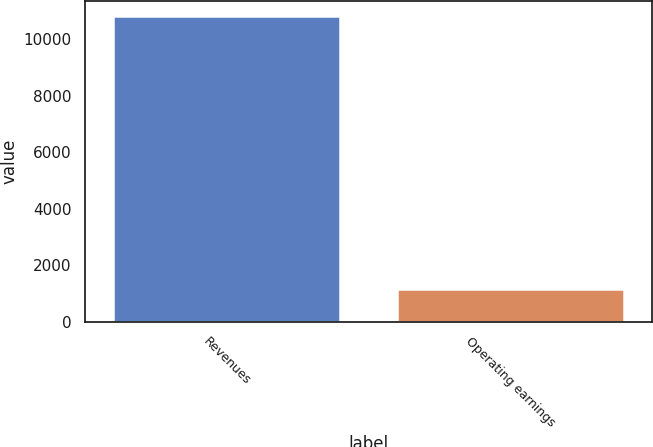Convert chart to OTSL. <chart><loc_0><loc_0><loc_500><loc_500><bar_chart><fcel>Revenues<fcel>Operating earnings<nl><fcel>10802<fcel>1151<nl></chart> 